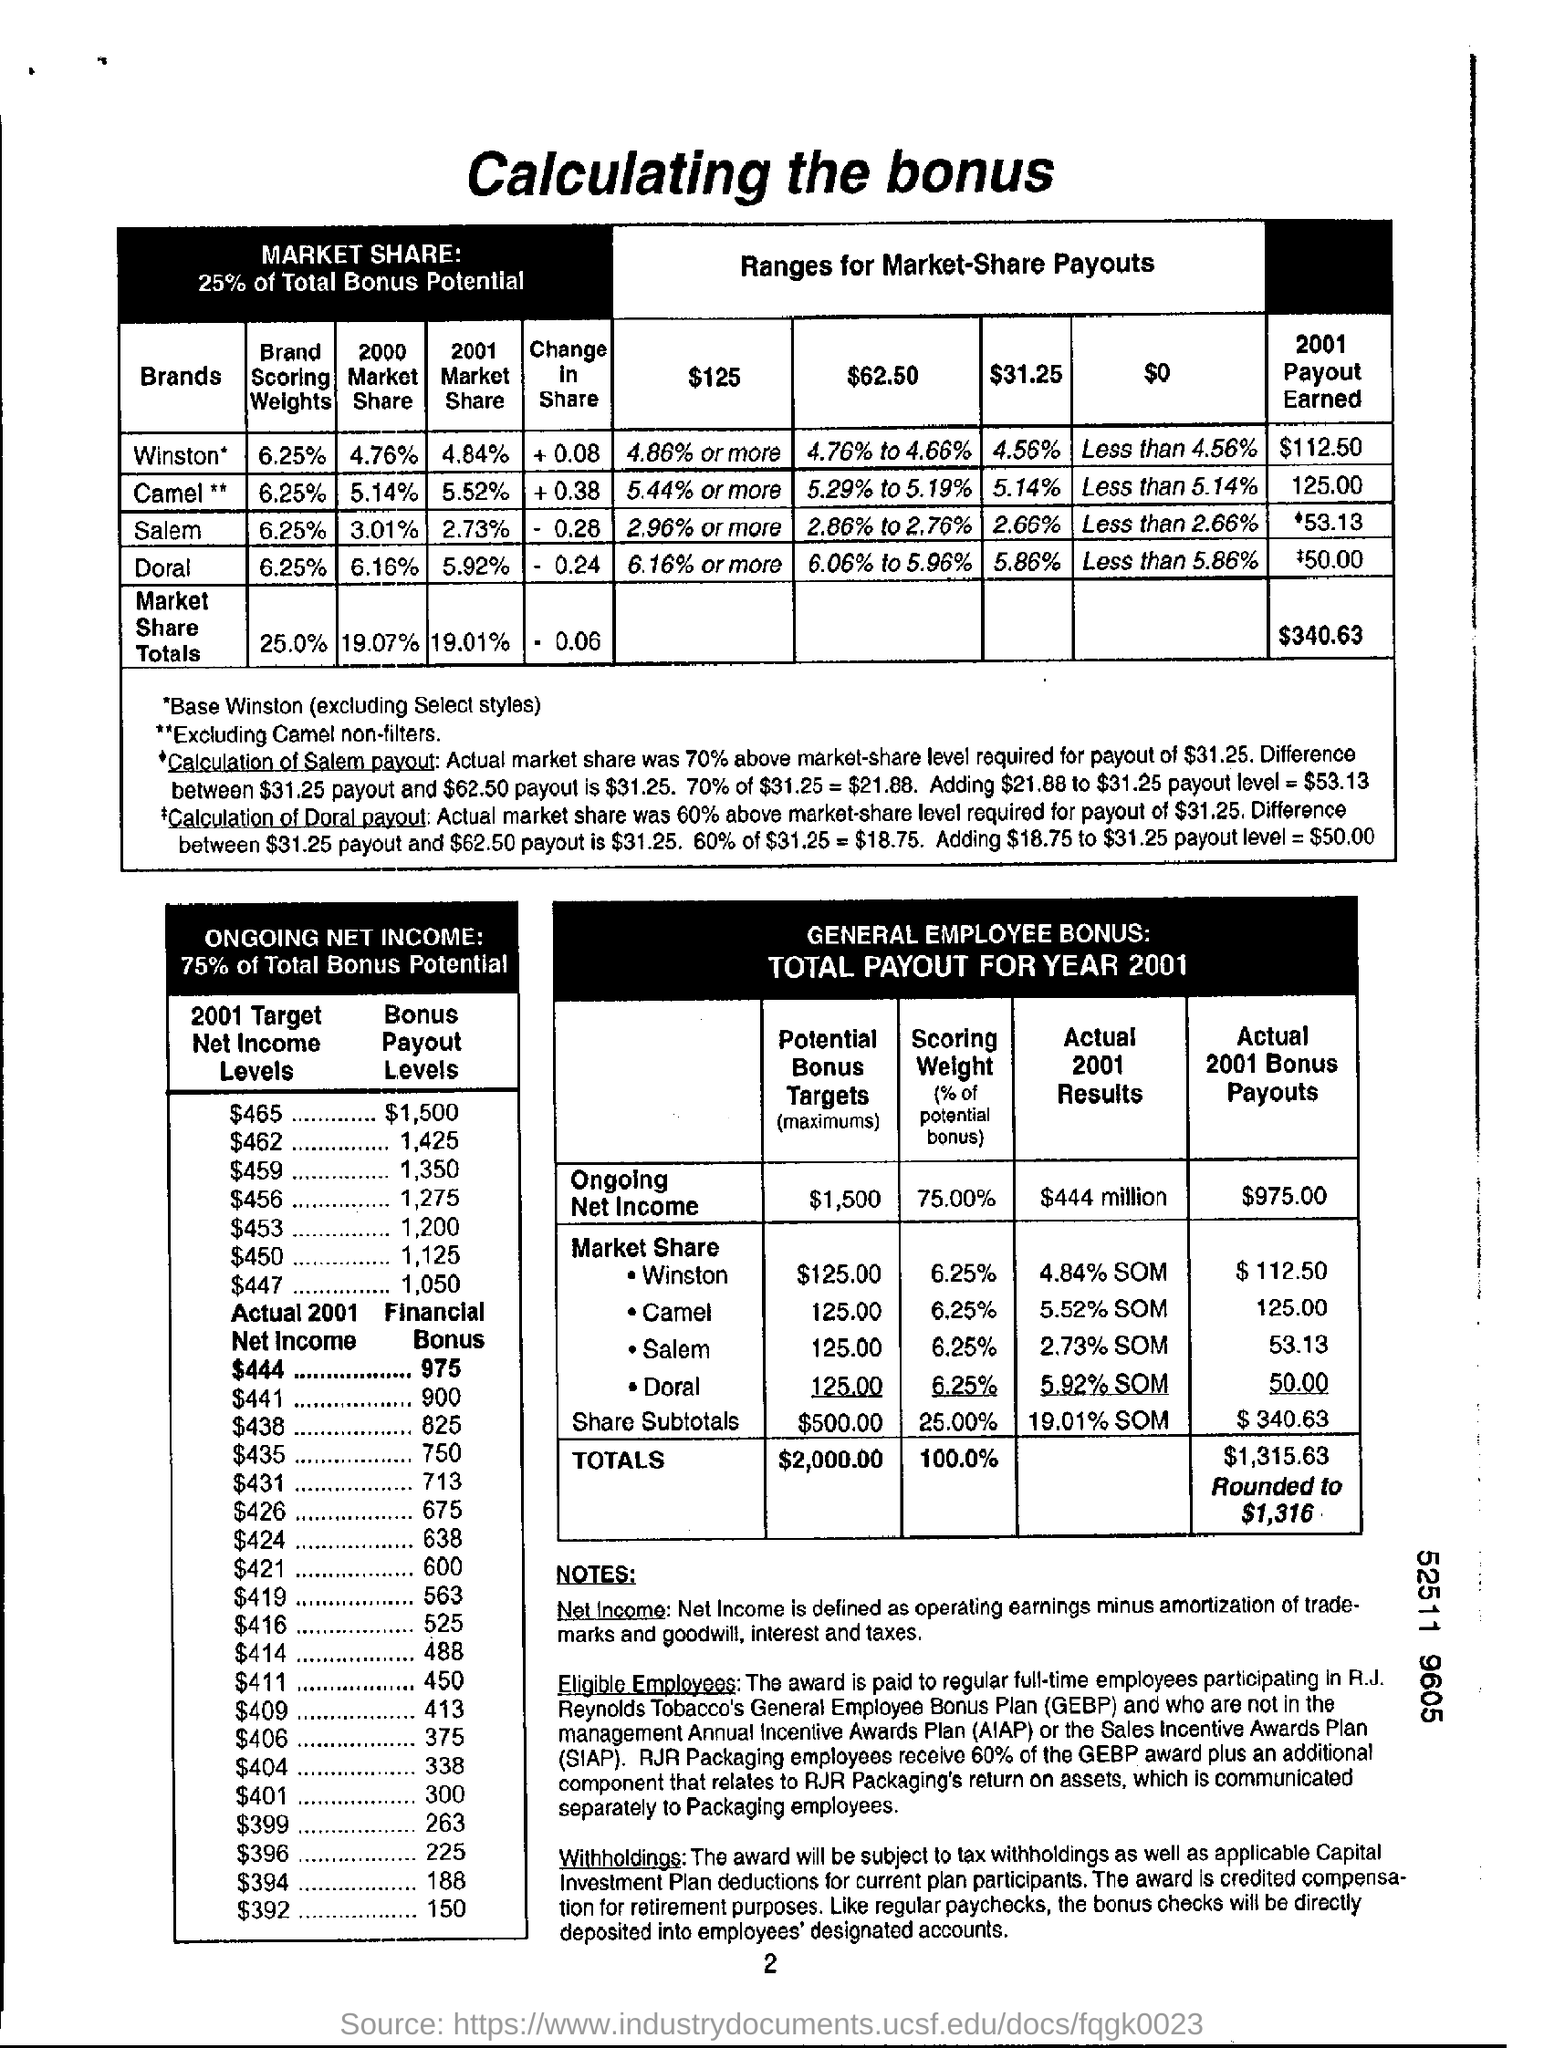Outline some significant characteristics in this image. The "Actual 2001 Bonus Payouts" for "Winston" in Market Share according to table 3 is $112.50. The financial bonus for $444 in 2001 according to Table 2 is $975. The "2001 Target Net Income Level" is equal to the "Bonus Payout Level" of $1,500, which is $465. The potential bonus target based on the general employee bonus table is $2,000.00. The value of the payout earned for the brand "Camel" in 2001 is 125.00. 